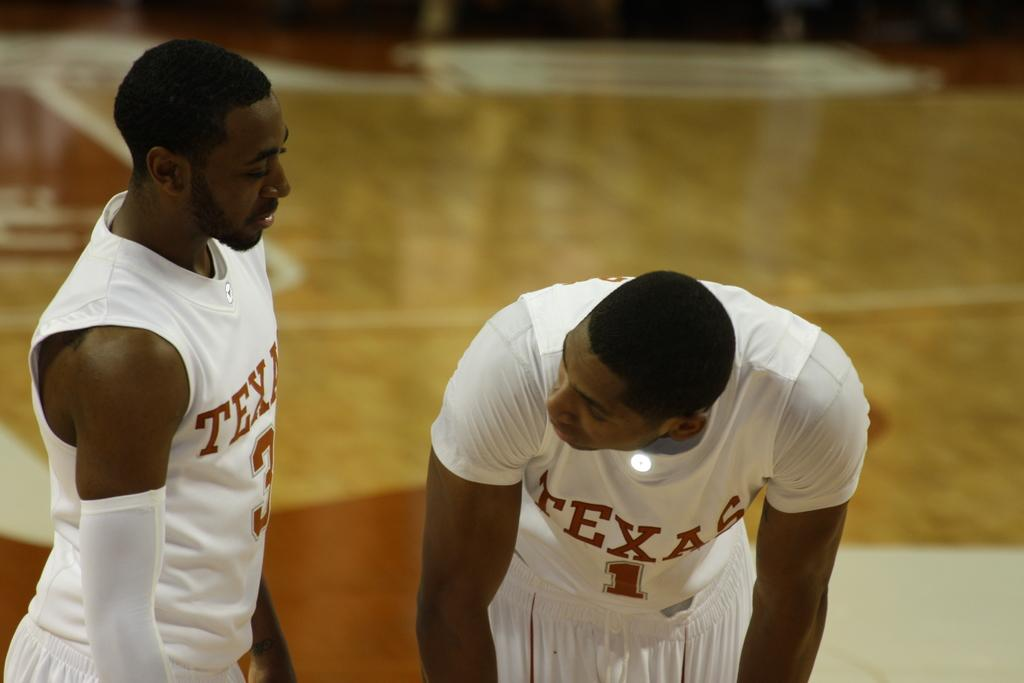<image>
Give a short and clear explanation of the subsequent image. a player has the number 1 on their jersey that is white 